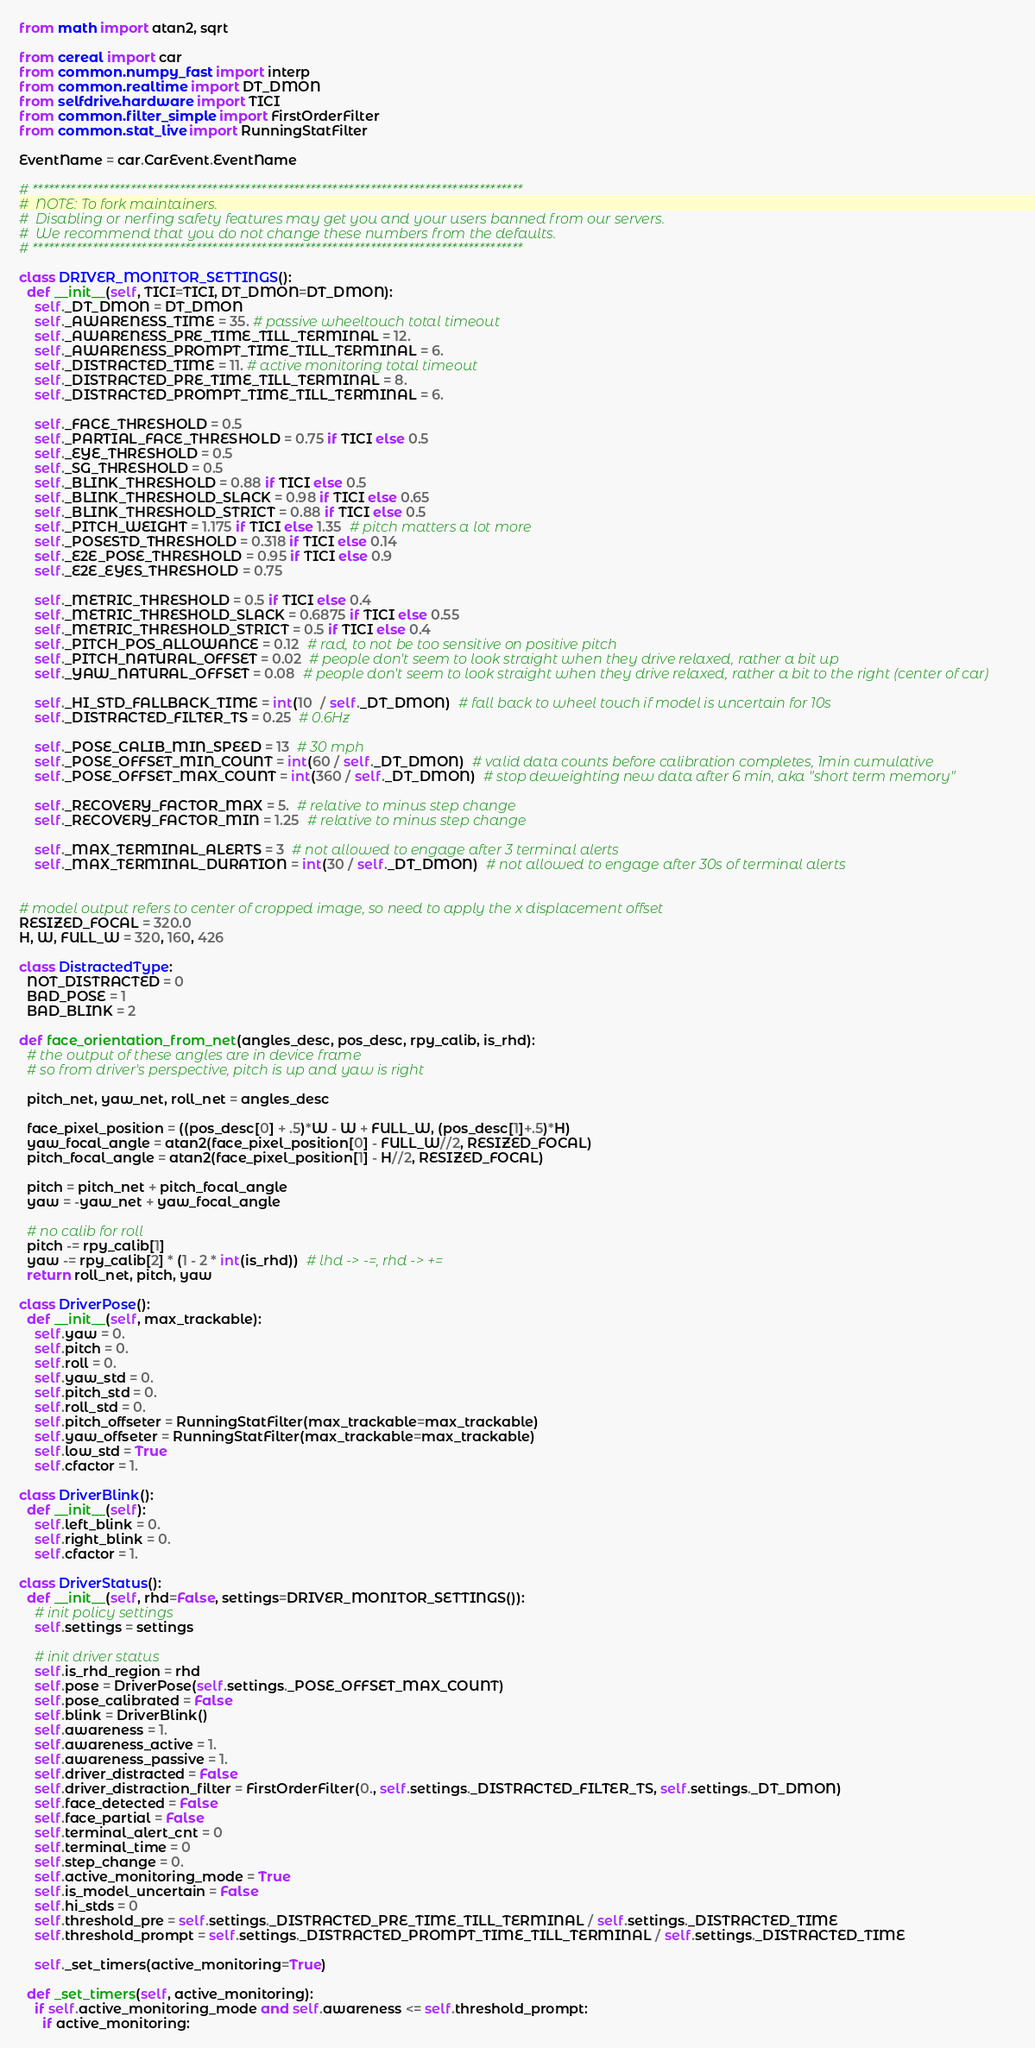Convert code to text. <code><loc_0><loc_0><loc_500><loc_500><_Python_>from math import atan2, sqrt

from cereal import car
from common.numpy_fast import interp
from common.realtime import DT_DMON
from selfdrive.hardware import TICI
from common.filter_simple import FirstOrderFilter
from common.stat_live import RunningStatFilter

EventName = car.CarEvent.EventName

# ******************************************************************************************
#  NOTE: To fork maintainers.
#  Disabling or nerfing safety features may get you and your users banned from our servers.
#  We recommend that you do not change these numbers from the defaults.
# ******************************************************************************************

class DRIVER_MONITOR_SETTINGS():
  def __init__(self, TICI=TICI, DT_DMON=DT_DMON):
    self._DT_DMON = DT_DMON
    self._AWARENESS_TIME = 35. # passive wheeltouch total timeout
    self._AWARENESS_PRE_TIME_TILL_TERMINAL = 12.
    self._AWARENESS_PROMPT_TIME_TILL_TERMINAL = 6.
    self._DISTRACTED_TIME = 11. # active monitoring total timeout
    self._DISTRACTED_PRE_TIME_TILL_TERMINAL = 8.
    self._DISTRACTED_PROMPT_TIME_TILL_TERMINAL = 6.

    self._FACE_THRESHOLD = 0.5
    self._PARTIAL_FACE_THRESHOLD = 0.75 if TICI else 0.5
    self._EYE_THRESHOLD = 0.5
    self._SG_THRESHOLD = 0.5
    self._BLINK_THRESHOLD = 0.88 if TICI else 0.5
    self._BLINK_THRESHOLD_SLACK = 0.98 if TICI else 0.65
    self._BLINK_THRESHOLD_STRICT = 0.88 if TICI else 0.5
    self._PITCH_WEIGHT = 1.175 if TICI else 1.35  # pitch matters a lot more
    self._POSESTD_THRESHOLD = 0.318 if TICI else 0.14
    self._E2E_POSE_THRESHOLD = 0.95 if TICI else 0.9
    self._E2E_EYES_THRESHOLD = 0.75

    self._METRIC_THRESHOLD = 0.5 if TICI else 0.4
    self._METRIC_THRESHOLD_SLACK = 0.6875 if TICI else 0.55
    self._METRIC_THRESHOLD_STRICT = 0.5 if TICI else 0.4
    self._PITCH_POS_ALLOWANCE = 0.12  # rad, to not be too sensitive on positive pitch
    self._PITCH_NATURAL_OFFSET = 0.02  # people don't seem to look straight when they drive relaxed, rather a bit up
    self._YAW_NATURAL_OFFSET = 0.08  # people don't seem to look straight when they drive relaxed, rather a bit to the right (center of car)

    self._HI_STD_FALLBACK_TIME = int(10  / self._DT_DMON)  # fall back to wheel touch if model is uncertain for 10s
    self._DISTRACTED_FILTER_TS = 0.25  # 0.6Hz

    self._POSE_CALIB_MIN_SPEED = 13  # 30 mph
    self._POSE_OFFSET_MIN_COUNT = int(60 / self._DT_DMON)  # valid data counts before calibration completes, 1min cumulative
    self._POSE_OFFSET_MAX_COUNT = int(360 / self._DT_DMON)  # stop deweighting new data after 6 min, aka "short term memory"

    self._RECOVERY_FACTOR_MAX = 5.  # relative to minus step change
    self._RECOVERY_FACTOR_MIN = 1.25  # relative to minus step change

    self._MAX_TERMINAL_ALERTS = 3  # not allowed to engage after 3 terminal alerts
    self._MAX_TERMINAL_DURATION = int(30 / self._DT_DMON)  # not allowed to engage after 30s of terminal alerts


# model output refers to center of cropped image, so need to apply the x displacement offset
RESIZED_FOCAL = 320.0
H, W, FULL_W = 320, 160, 426

class DistractedType:
  NOT_DISTRACTED = 0
  BAD_POSE = 1
  BAD_BLINK = 2

def face_orientation_from_net(angles_desc, pos_desc, rpy_calib, is_rhd):
  # the output of these angles are in device frame
  # so from driver's perspective, pitch is up and yaw is right

  pitch_net, yaw_net, roll_net = angles_desc

  face_pixel_position = ((pos_desc[0] + .5)*W - W + FULL_W, (pos_desc[1]+.5)*H)
  yaw_focal_angle = atan2(face_pixel_position[0] - FULL_W//2, RESIZED_FOCAL)
  pitch_focal_angle = atan2(face_pixel_position[1] - H//2, RESIZED_FOCAL)

  pitch = pitch_net + pitch_focal_angle
  yaw = -yaw_net + yaw_focal_angle

  # no calib for roll
  pitch -= rpy_calib[1]
  yaw -= rpy_calib[2] * (1 - 2 * int(is_rhd))  # lhd -> -=, rhd -> +=
  return roll_net, pitch, yaw

class DriverPose():
  def __init__(self, max_trackable):
    self.yaw = 0.
    self.pitch = 0.
    self.roll = 0.
    self.yaw_std = 0.
    self.pitch_std = 0.
    self.roll_std = 0.
    self.pitch_offseter = RunningStatFilter(max_trackable=max_trackable)
    self.yaw_offseter = RunningStatFilter(max_trackable=max_trackable)
    self.low_std = True
    self.cfactor = 1.

class DriverBlink():
  def __init__(self):
    self.left_blink = 0.
    self.right_blink = 0.
    self.cfactor = 1.

class DriverStatus():
  def __init__(self, rhd=False, settings=DRIVER_MONITOR_SETTINGS()):
    # init policy settings
    self.settings = settings

    # init driver status
    self.is_rhd_region = rhd
    self.pose = DriverPose(self.settings._POSE_OFFSET_MAX_COUNT)
    self.pose_calibrated = False
    self.blink = DriverBlink()
    self.awareness = 1.
    self.awareness_active = 1.
    self.awareness_passive = 1.
    self.driver_distracted = False
    self.driver_distraction_filter = FirstOrderFilter(0., self.settings._DISTRACTED_FILTER_TS, self.settings._DT_DMON)
    self.face_detected = False
    self.face_partial = False
    self.terminal_alert_cnt = 0
    self.terminal_time = 0
    self.step_change = 0.
    self.active_monitoring_mode = True
    self.is_model_uncertain = False
    self.hi_stds = 0
    self.threshold_pre = self.settings._DISTRACTED_PRE_TIME_TILL_TERMINAL / self.settings._DISTRACTED_TIME
    self.threshold_prompt = self.settings._DISTRACTED_PROMPT_TIME_TILL_TERMINAL / self.settings._DISTRACTED_TIME

    self._set_timers(active_monitoring=True)

  def _set_timers(self, active_monitoring):
    if self.active_monitoring_mode and self.awareness <= self.threshold_prompt:
      if active_monitoring:</code> 